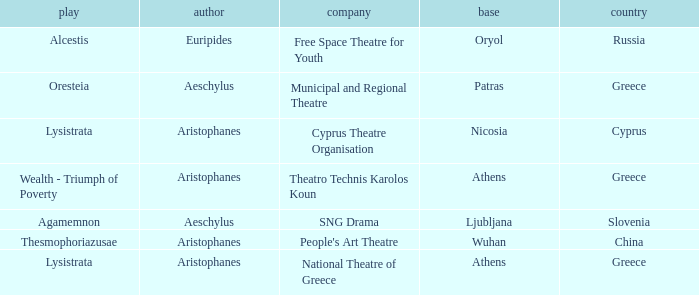What is the theatrical production when the group is national theatre of greece? Lysistrata. 